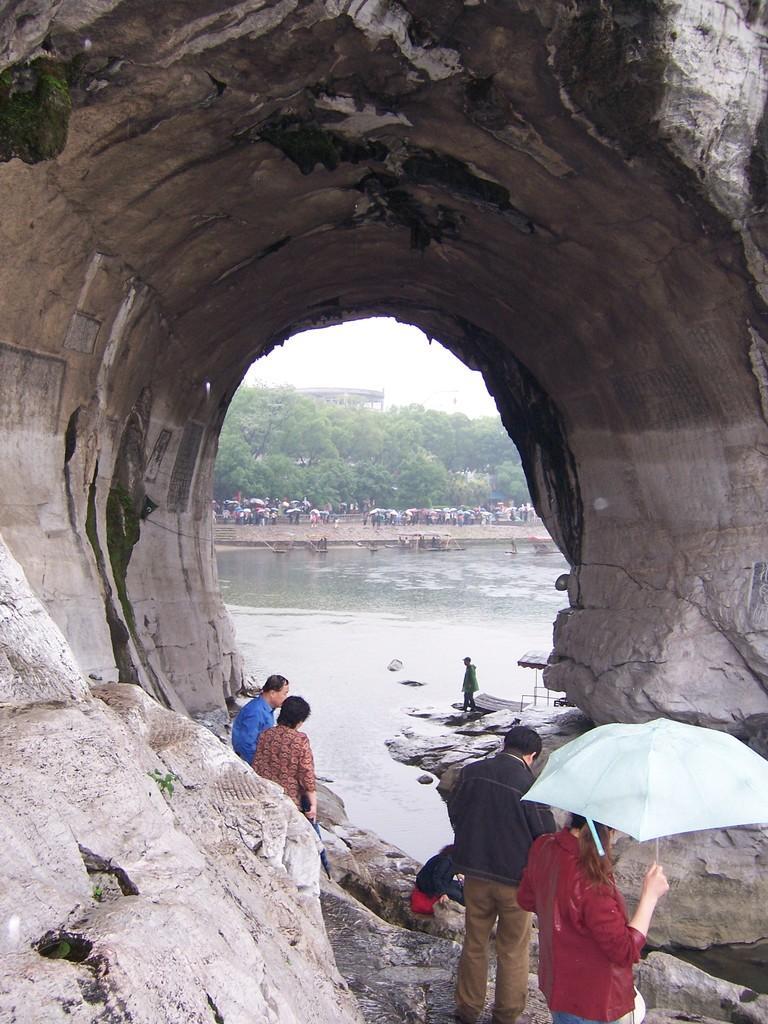Can you describe this image briefly? There are few persons standing under a cave and there are trees,few people and water in the background. 